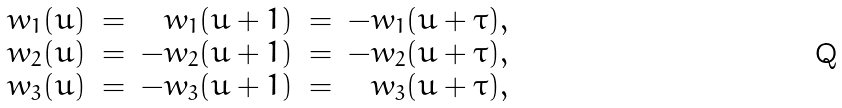Convert formula to latex. <formula><loc_0><loc_0><loc_500><loc_500>\begin{array} { r c r c r } w _ { 1 } ( u ) & = & w _ { 1 } ( u + 1 ) & = & - w _ { 1 } ( u + \tau ) , \\ w _ { 2 } ( u ) & = & - w _ { 2 } ( u + 1 ) & = & - w _ { 2 } ( u + \tau ) , \\ w _ { 3 } ( u ) & = & - w _ { 3 } ( u + 1 ) & = & w _ { 3 } ( u + \tau ) , \end{array}</formula> 